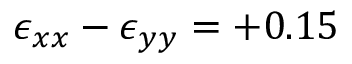<formula> <loc_0><loc_0><loc_500><loc_500>\epsilon _ { x x } - \epsilon _ { y y } = + 0 . 1 5 \</formula> 